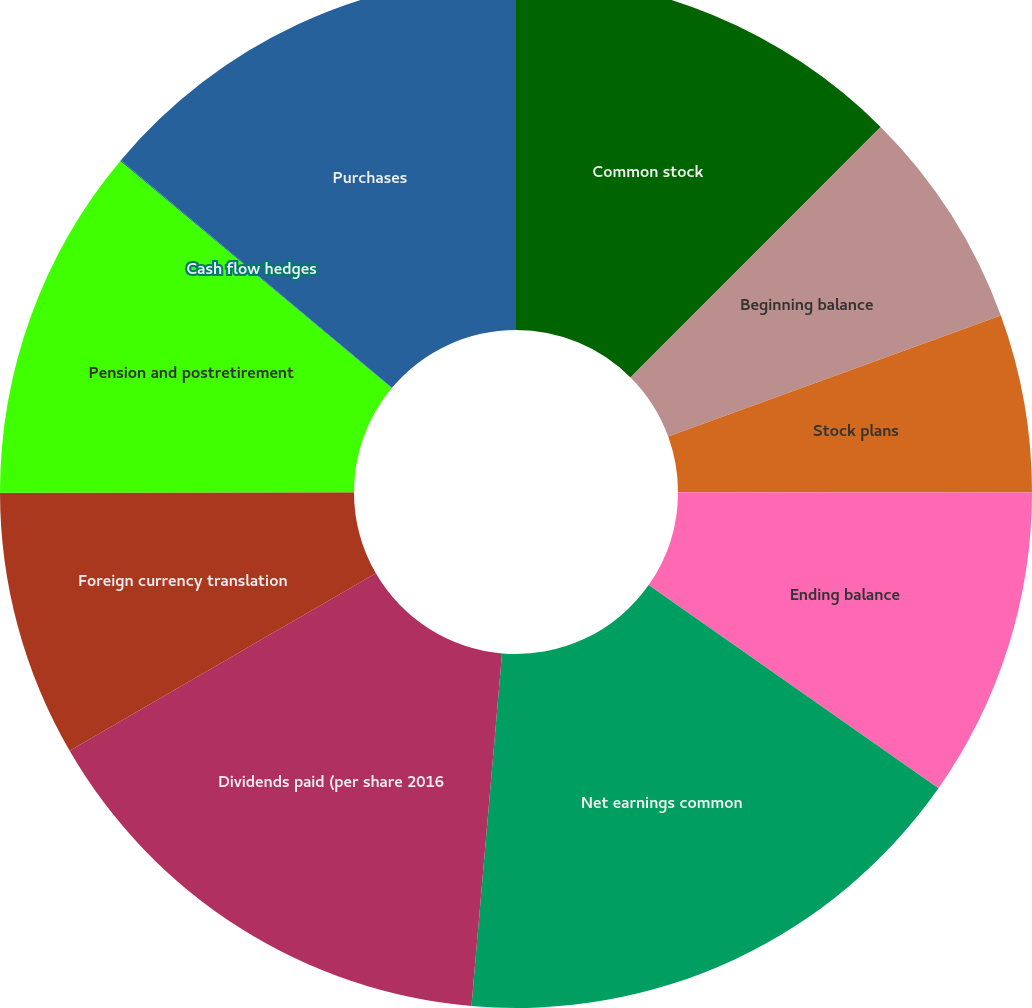Convert chart. <chart><loc_0><loc_0><loc_500><loc_500><pie_chart><fcel>Common stock<fcel>Beginning balance<fcel>Stock plans<fcel>Ending balance<fcel>Net earnings common<fcel>Dividends paid (per share 2016<fcel>Foreign currency translation<fcel>Pension and postretirement<fcel>Cash flow hedges<fcel>Purchases<nl><fcel>12.49%<fcel>6.95%<fcel>5.57%<fcel>9.72%<fcel>16.64%<fcel>15.26%<fcel>8.34%<fcel>11.11%<fcel>0.03%<fcel>13.88%<nl></chart> 